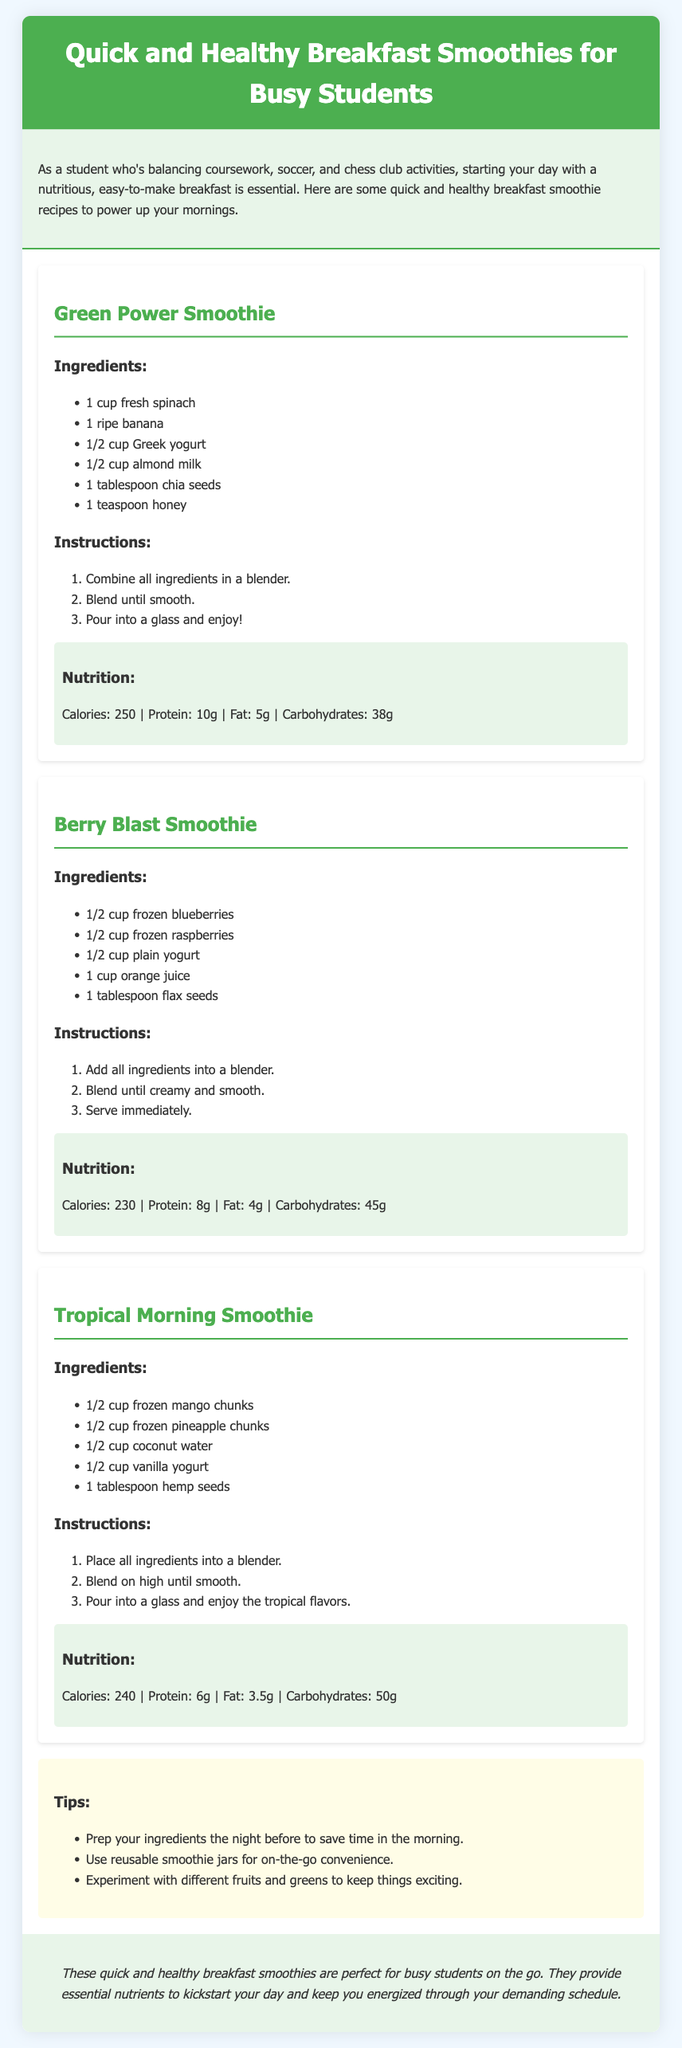what is the title of the document? The title, as stated in the header, is "Quick and Healthy Breakfast Smoothies for Busy Students."
Answer: Quick and Healthy Breakfast Smoothies for Busy Students how many smoothie recipes are provided? The document contains three smoothie recipes listed in separate smoothie cards.
Answer: Three what is one ingredient in the Green Power Smoothie? One ingredient is mentioned in the ingredients list of the Green Power Smoothie section.
Answer: Fresh spinach how many calories does the Berry Blast Smoothie have? The calorie count for the Berry Blast Smoothie is stated in the nutrition section.
Answer: 230 what is the protein content of the Tropical Morning Smoothie? The document specifies the protein content in the nutrition section for that smoothie.
Answer: 6g which smoothie contains chia seeds? The ingredient list in the Green Power Smoothie identifies this ingredient.
Answer: Green Power Smoothie what is a tip mentioned for preparing smoothies? The tips section highlights a useful strategy for smoothie preparation.
Answer: Prep your ingredients the night before what is the fat content of the Green Power Smoothie? The fat content is included in the nutritional information section of the Green Power Smoothie.
Answer: 5g what should you blend in the Berry Blast Smoothie? The instructions specify what to blend in this smoothie recipe.
Answer: All ingredients what type of yogurt is used in the Tropical Morning Smoothie? The ingredients list mentions the specific type of yogurt used in this recipe.
Answer: Vanilla yogurt 